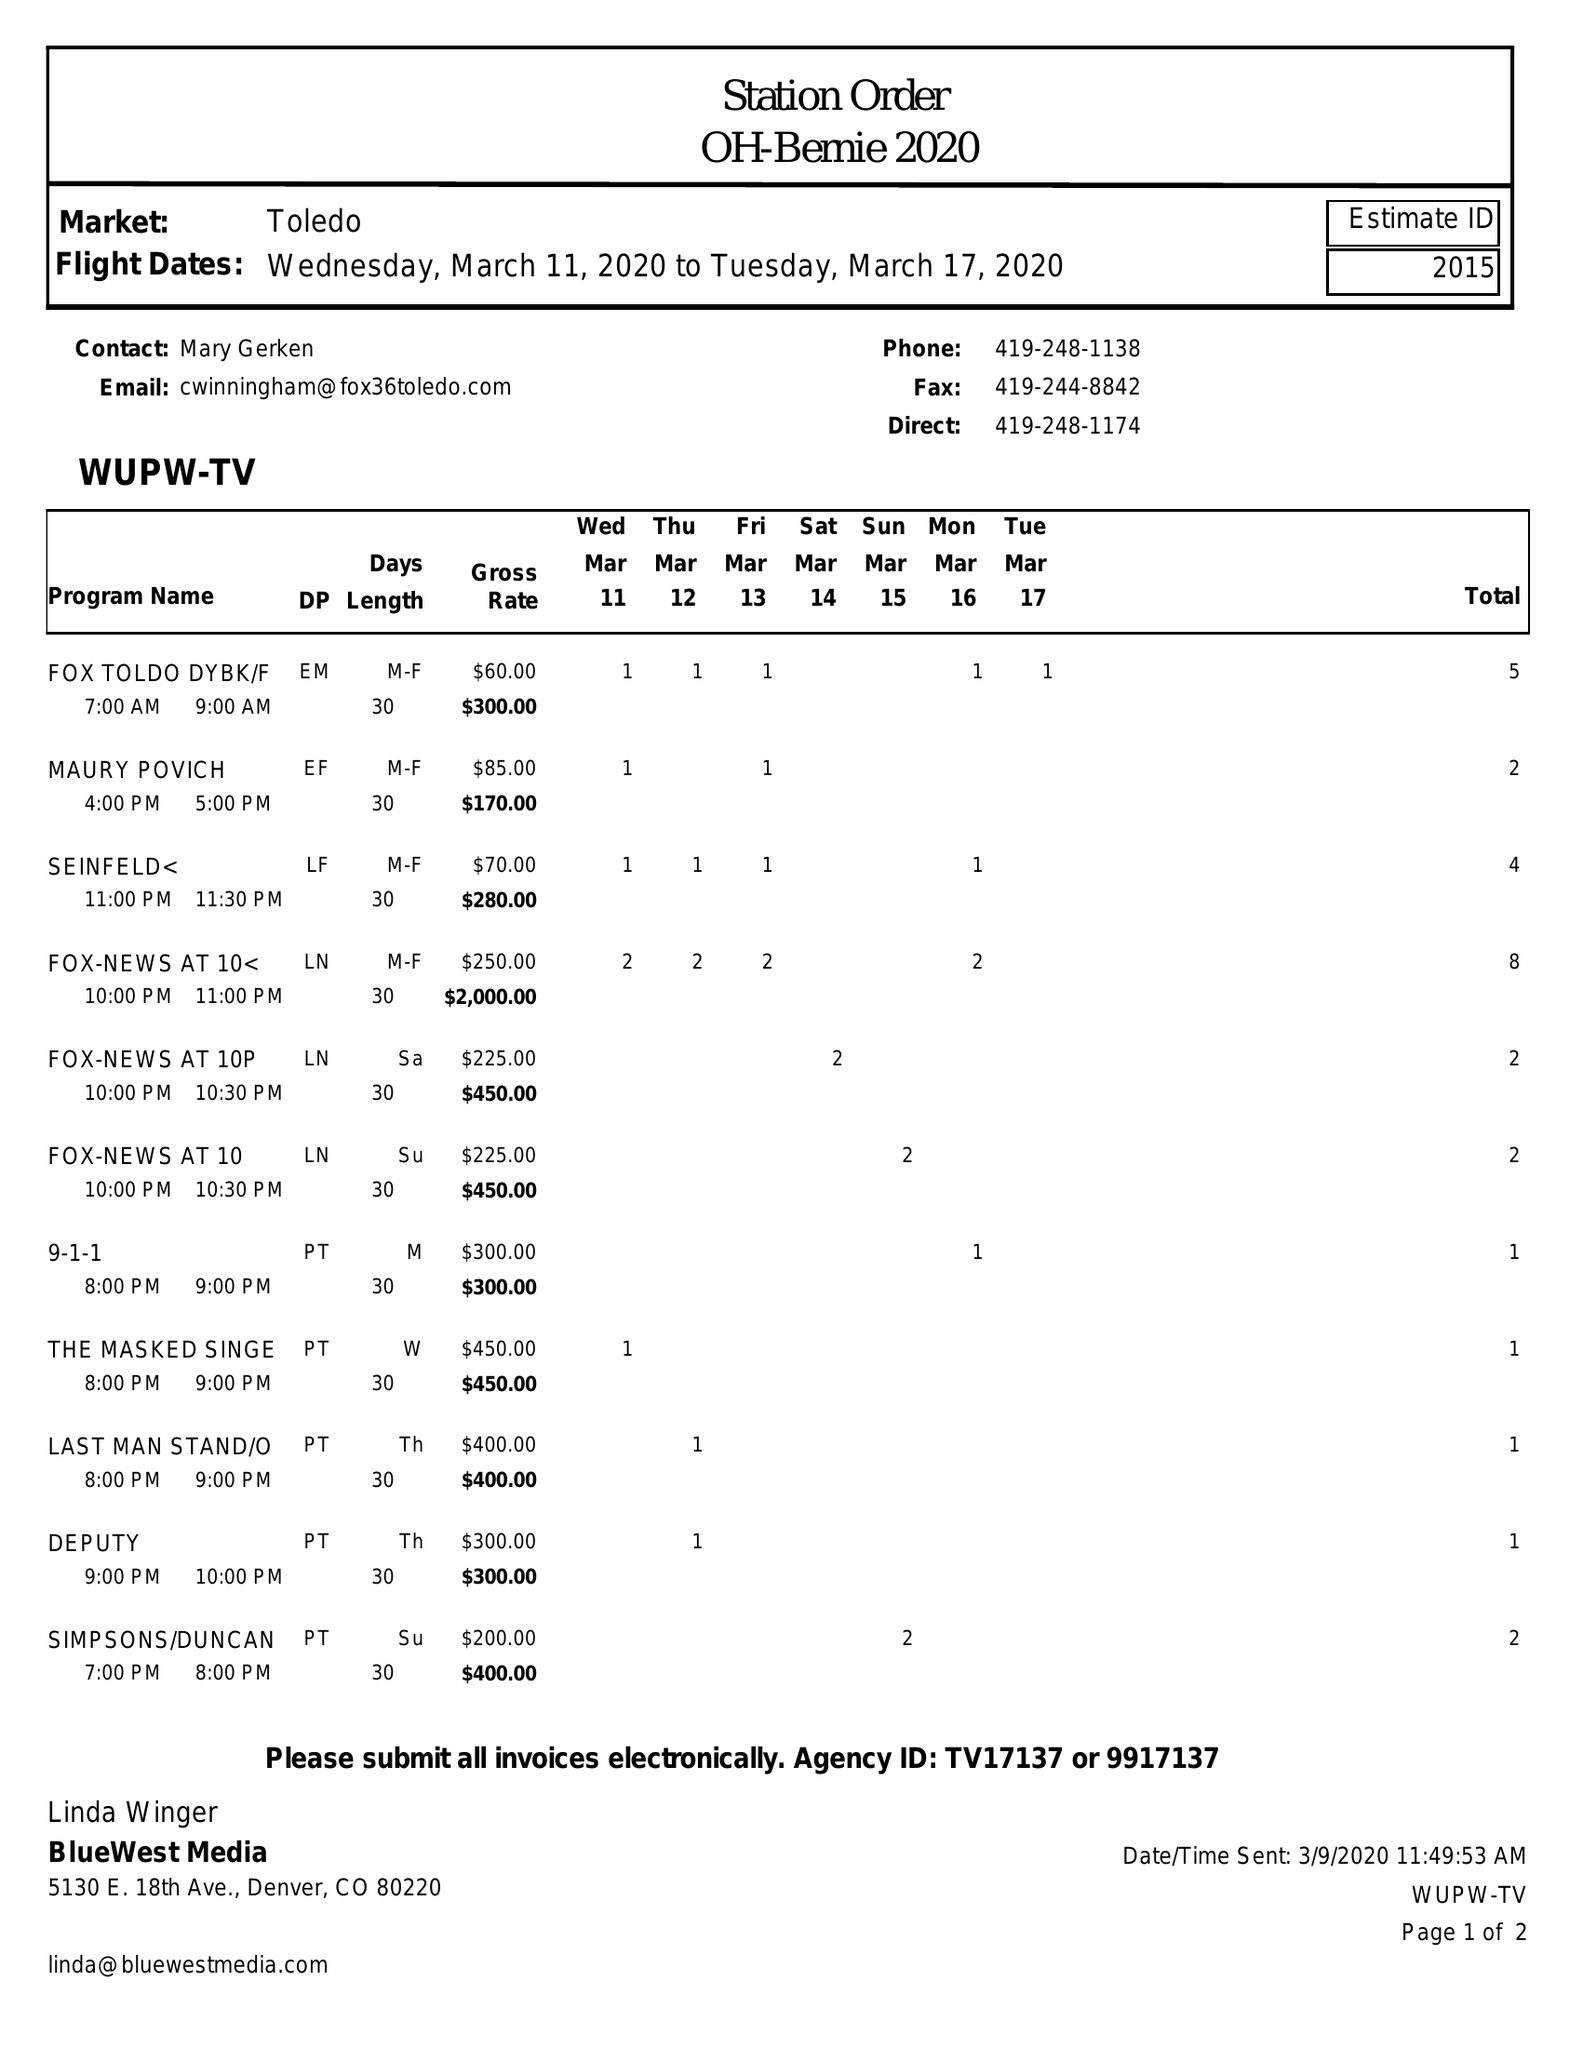What is the value for the advertiser?
Answer the question using a single word or phrase. OH-BERNIE 2020 